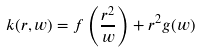<formula> <loc_0><loc_0><loc_500><loc_500>k ( r , w ) = f \left ( \frac { r ^ { 2 } } { w } \right ) + r ^ { 2 } g ( w )</formula> 